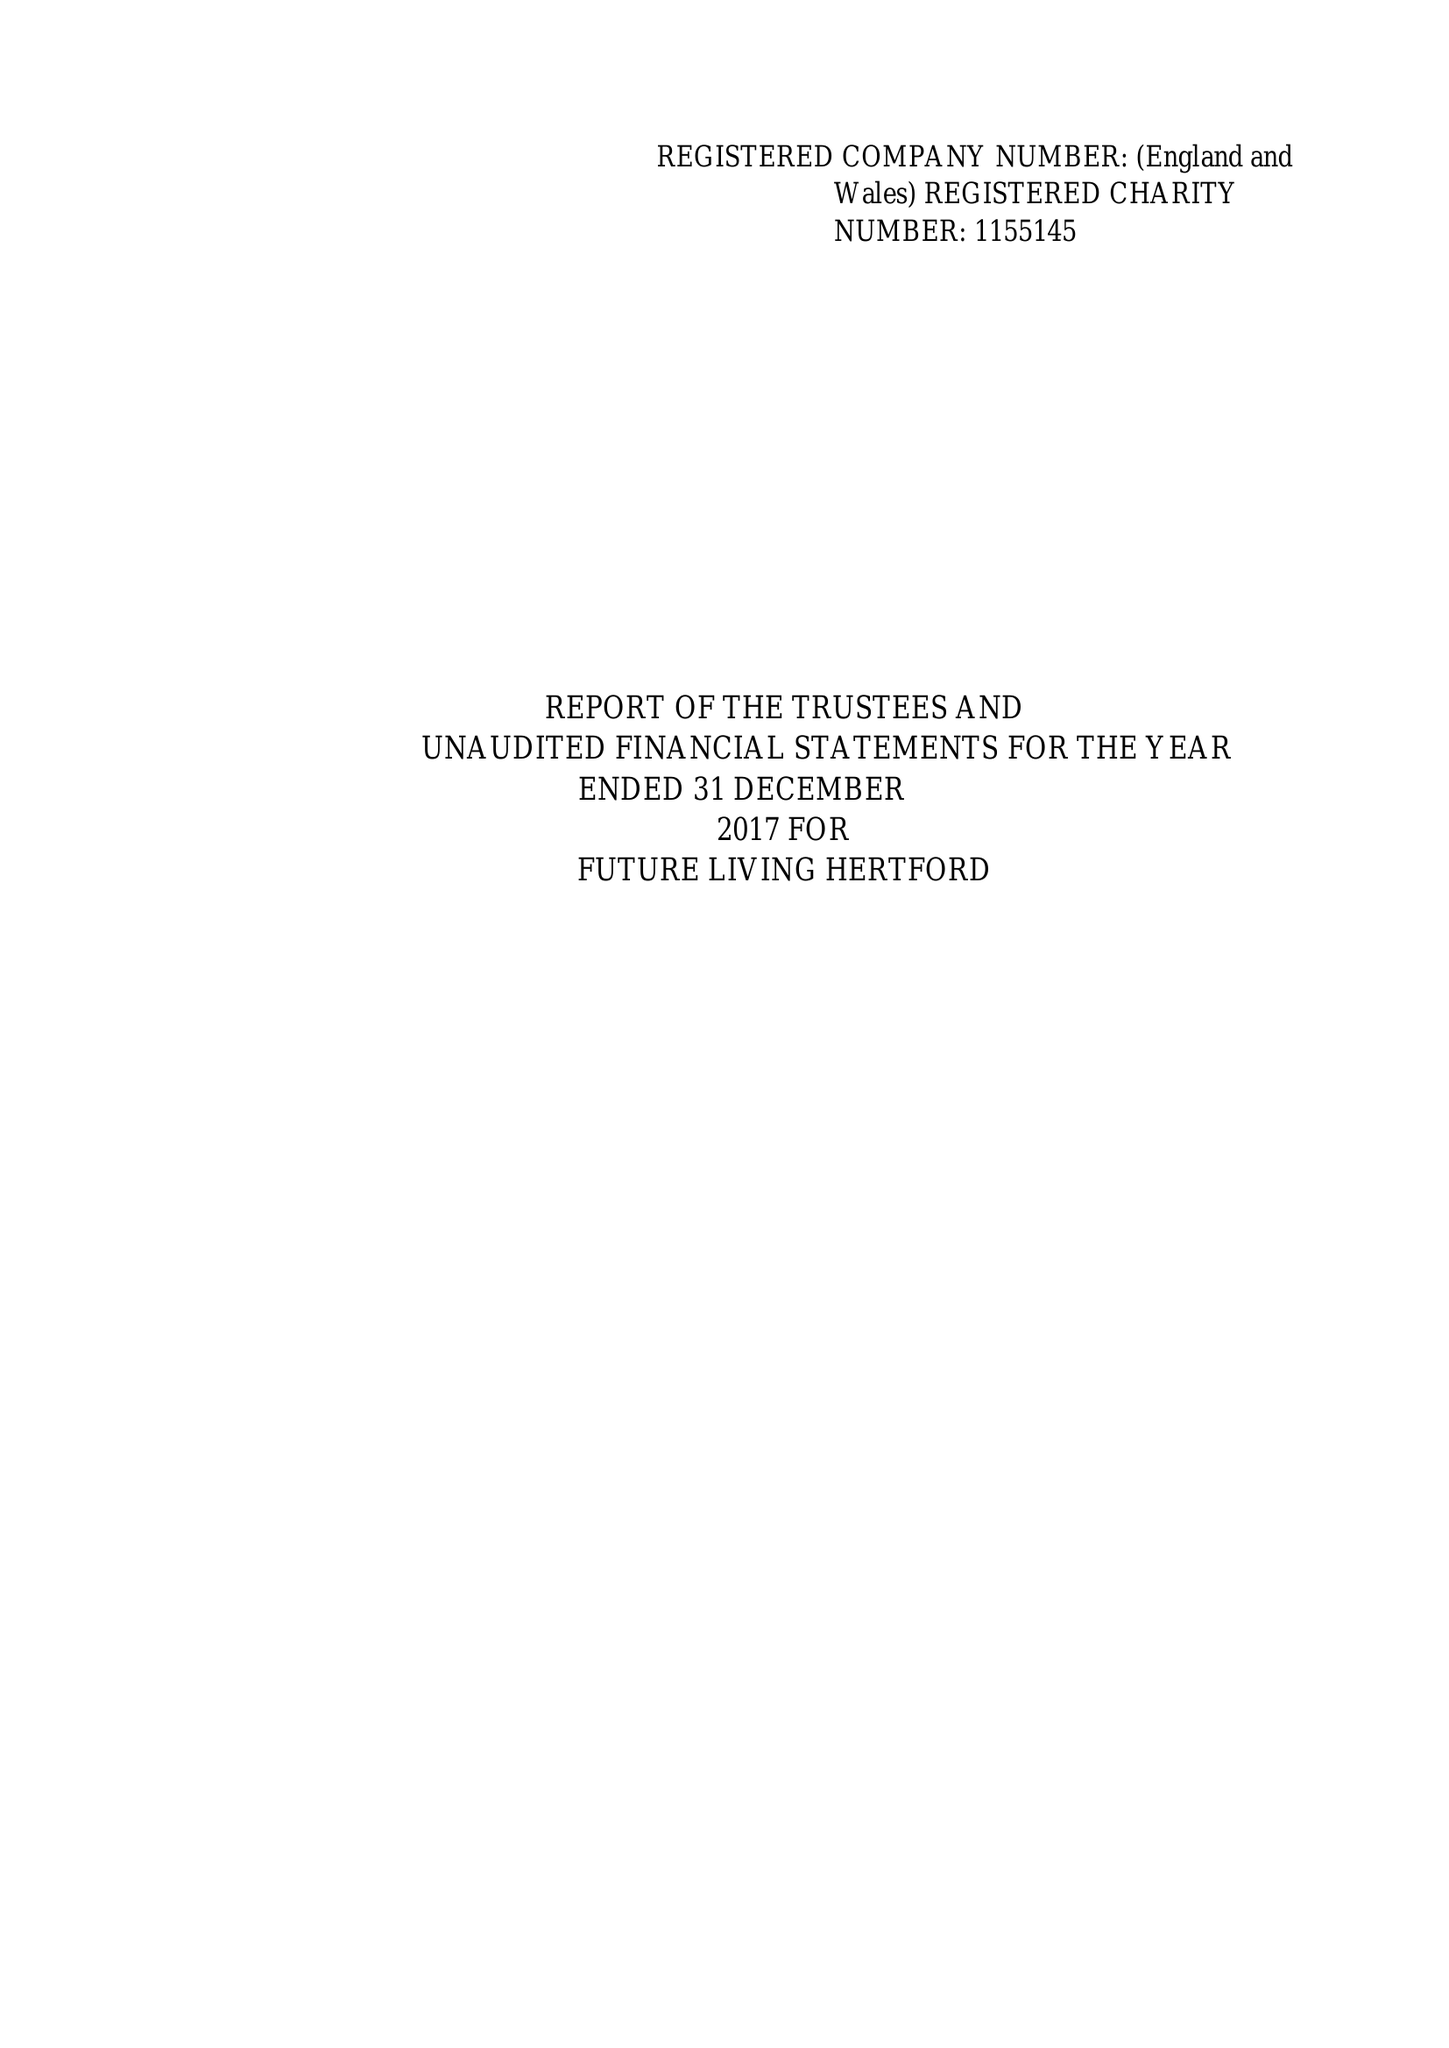What is the value for the charity_number?
Answer the question using a single word or phrase. 1155145 